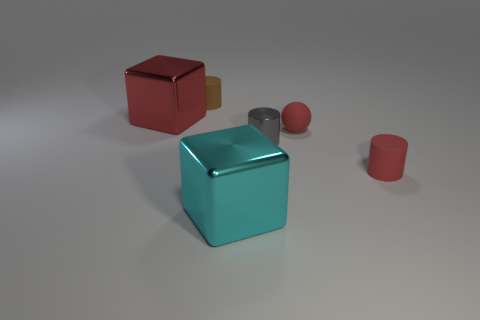Subtract all red cylinders. How many cylinders are left? 2 Subtract 1 red blocks. How many objects are left? 5 Subtract all cubes. How many objects are left? 4 Subtract 1 spheres. How many spheres are left? 0 Subtract all gray cubes. Subtract all purple cylinders. How many cubes are left? 2 Subtract all blue cylinders. How many blue cubes are left? 0 Subtract all big rubber balls. Subtract all small brown matte cylinders. How many objects are left? 5 Add 3 small brown cylinders. How many small brown cylinders are left? 4 Add 3 big green metal cylinders. How many big green metal cylinders exist? 3 Add 3 tiny blue matte cubes. How many objects exist? 9 